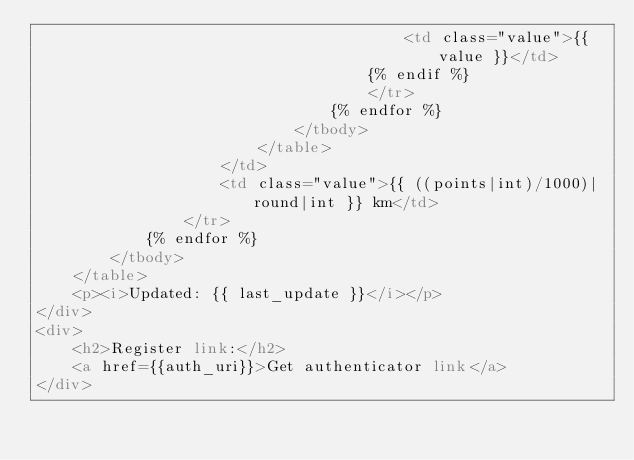Convert code to text. <code><loc_0><loc_0><loc_500><loc_500><_HTML_>										<td class="value">{{ value }}</td>
									{% endif %}
									</tr>
								{% endfor %}
							</tbody>
						</table>
					</td>
					<td class="value">{{ ((points|int)/1000)|round|int }} km</td>
				</tr>
			{% endfor %}
		</tbody>
	</table>
	<p><i>Updated: {{ last_update }}</i></p>
</div>
<div>
	<h2>Register link:</h2>
	<a href={{auth_uri}}>Get authenticator link</a>
</div></code> 